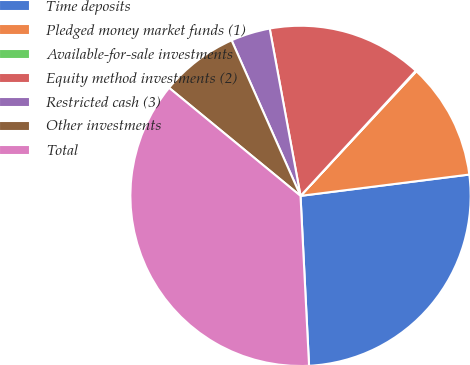Convert chart. <chart><loc_0><loc_0><loc_500><loc_500><pie_chart><fcel>Time deposits<fcel>Pledged money market funds (1)<fcel>Available-for-sale investments<fcel>Equity method investments (2)<fcel>Restricted cash (3)<fcel>Other investments<fcel>Total<nl><fcel>26.2%<fcel>11.08%<fcel>0.08%<fcel>14.74%<fcel>3.74%<fcel>7.41%<fcel>36.75%<nl></chart> 